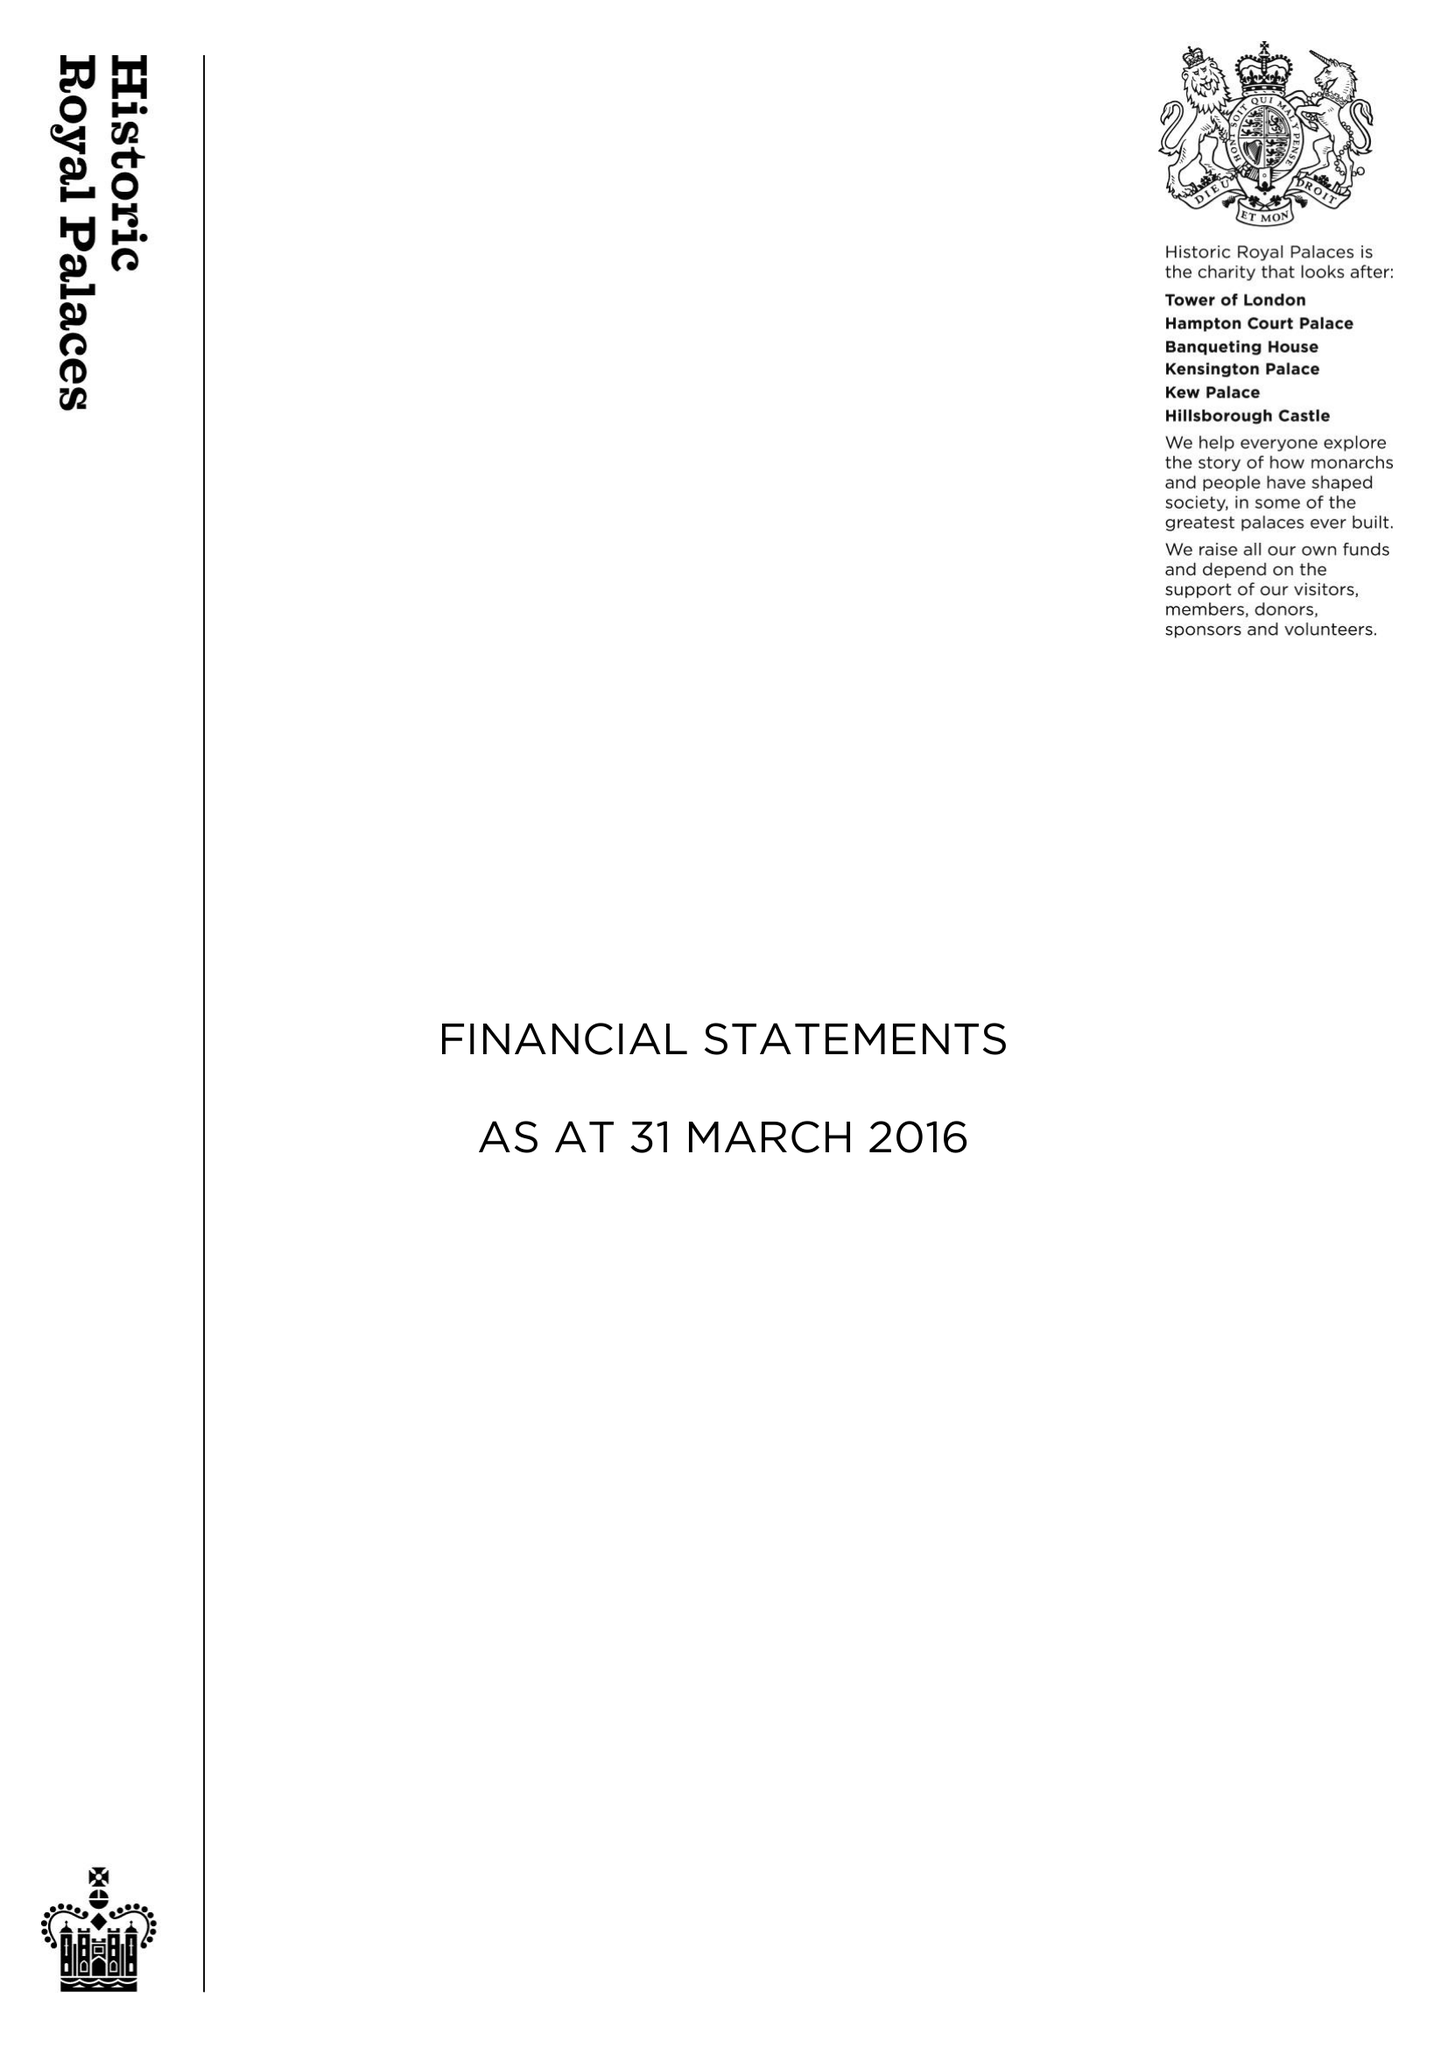What is the value for the spending_annually_in_british_pounds?
Answer the question using a single word or phrase. 88463000.00 